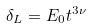<formula> <loc_0><loc_0><loc_500><loc_500>\delta _ { L } = E _ { 0 } t ^ { 3 \nu }</formula> 